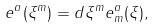<formula> <loc_0><loc_0><loc_500><loc_500>e ^ { a } ( \xi ^ { m } ) = d \xi ^ { m } e ^ { a } _ { m } ( \xi ) ,</formula> 